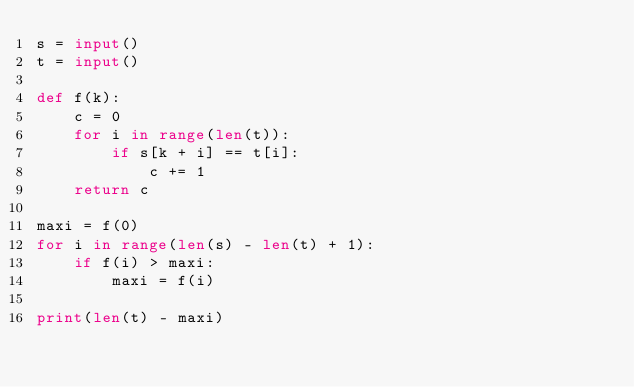Convert code to text. <code><loc_0><loc_0><loc_500><loc_500><_Python_>s = input()
t = input()

def f(k):
    c = 0
    for i in range(len(t)):
        if s[k + i] == t[i]:
            c += 1
    return c

maxi = f(0)
for i in range(len(s) - len(t) + 1):
    if f(i) > maxi:
        maxi = f(i)

print(len(t) - maxi)</code> 